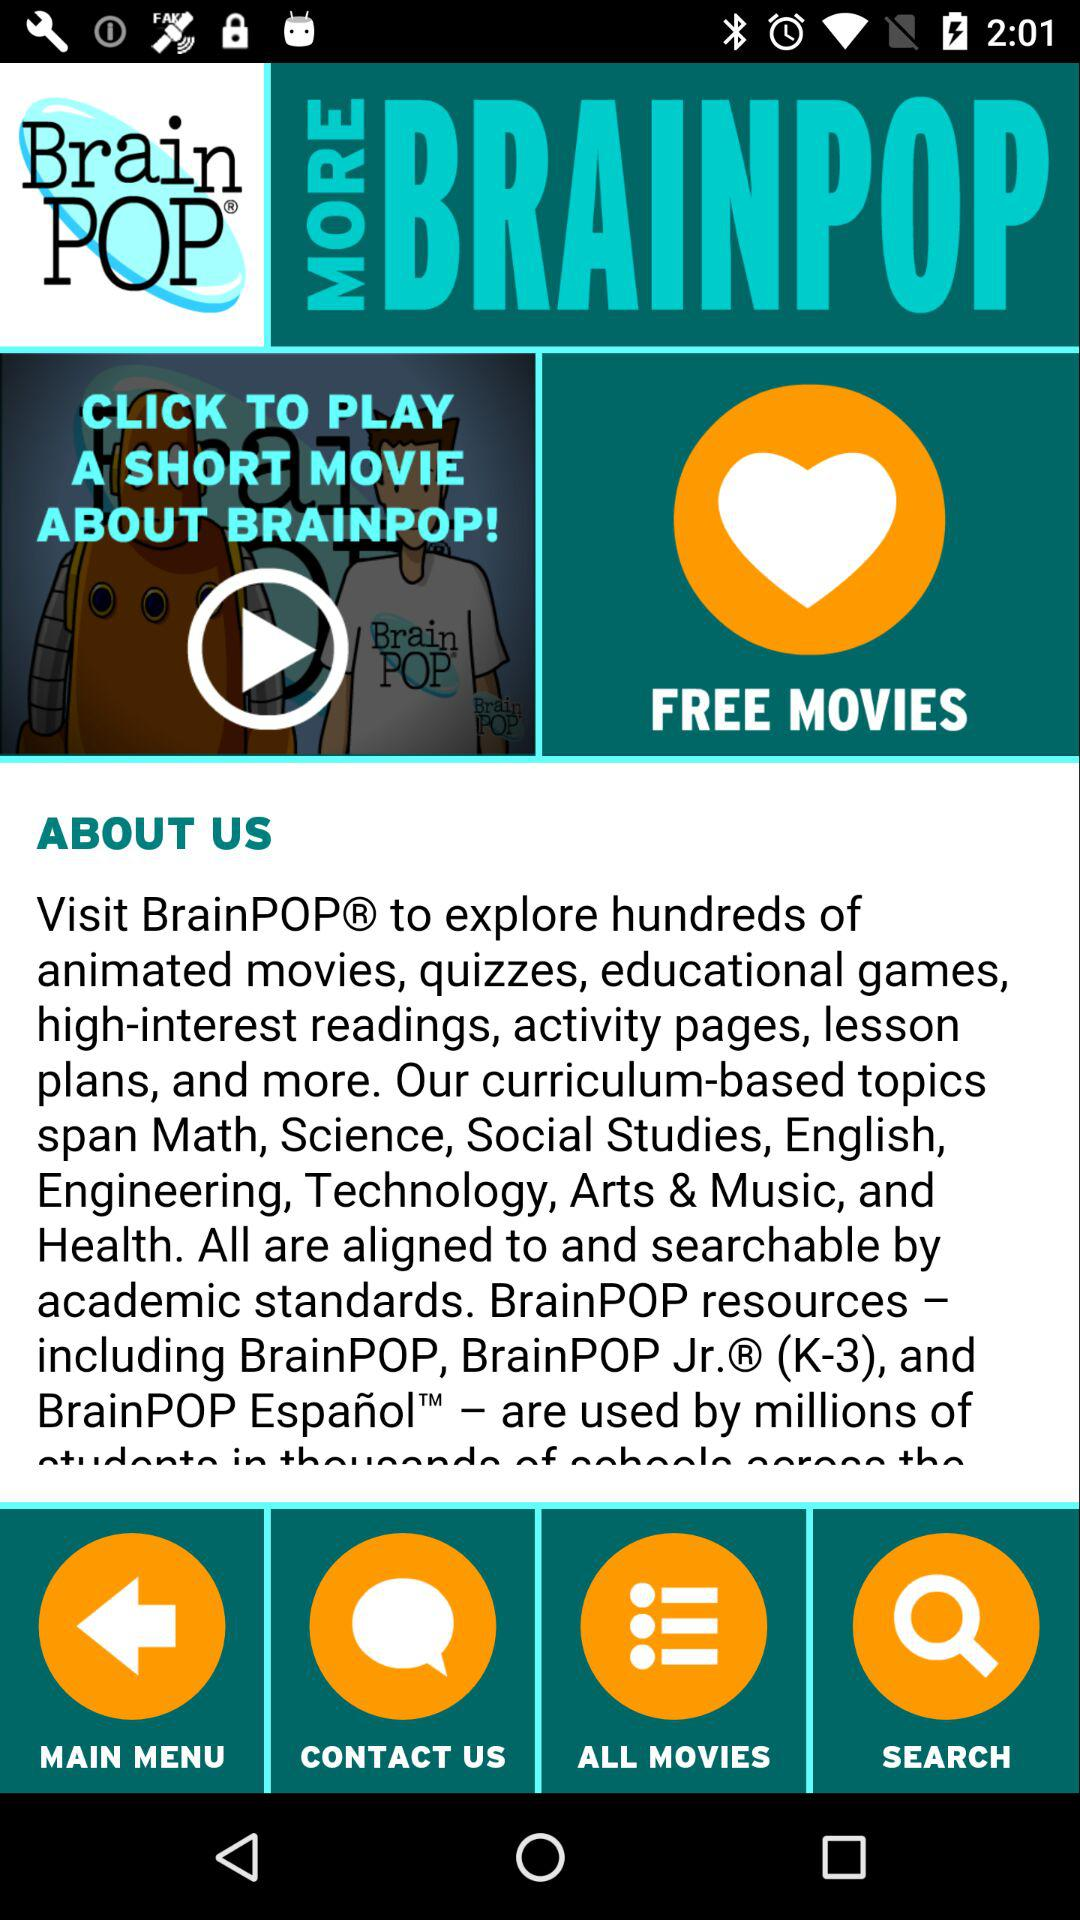What is the name of the application? The name of the application is "Brain POP". 